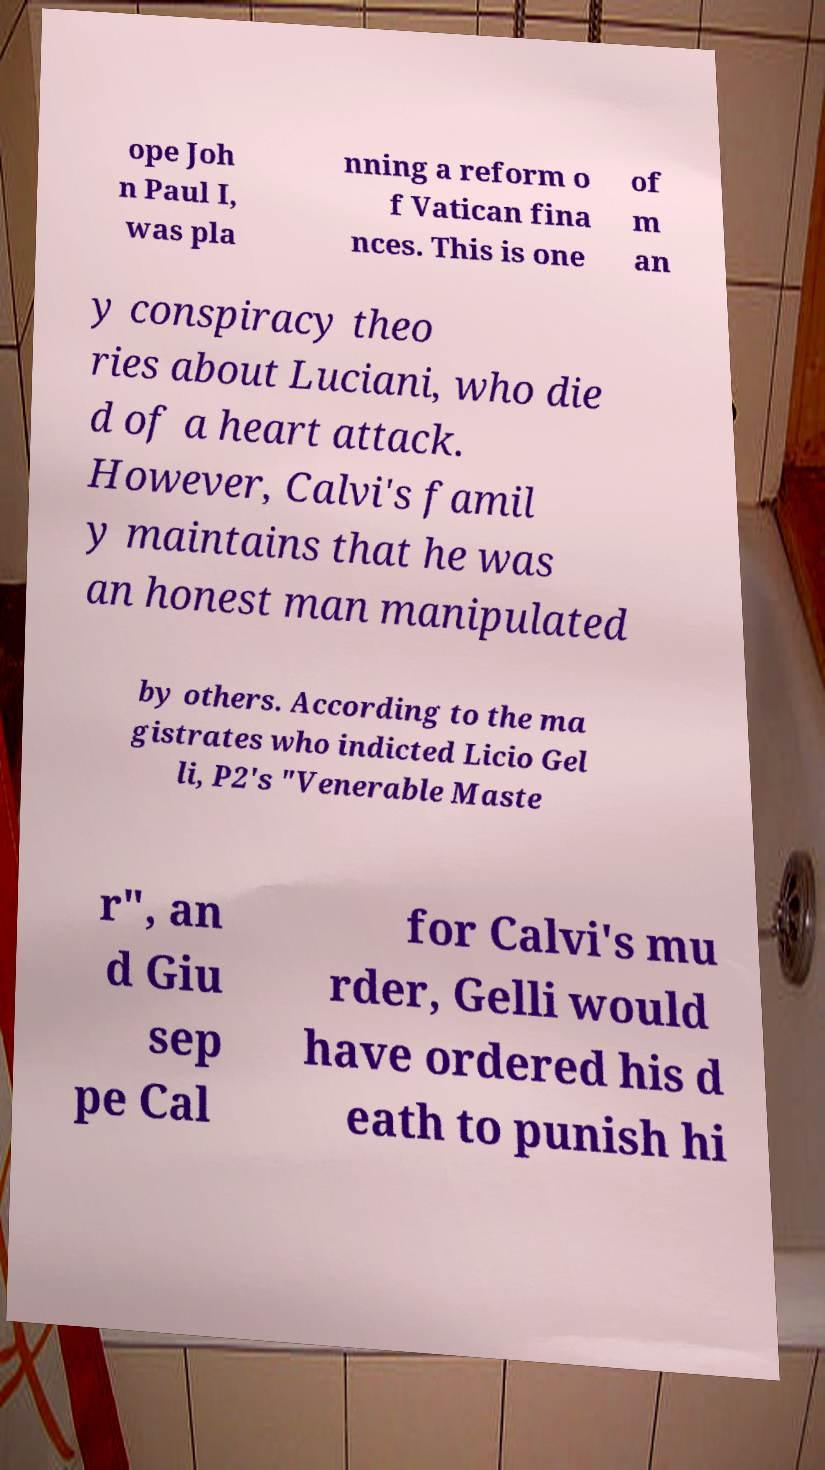Can you accurately transcribe the text from the provided image for me? ope Joh n Paul I, was pla nning a reform o f Vatican fina nces. This is one of m an y conspiracy theo ries about Luciani, who die d of a heart attack. However, Calvi's famil y maintains that he was an honest man manipulated by others. According to the ma gistrates who indicted Licio Gel li, P2's "Venerable Maste r", an d Giu sep pe Cal for Calvi's mu rder, Gelli would have ordered his d eath to punish hi 